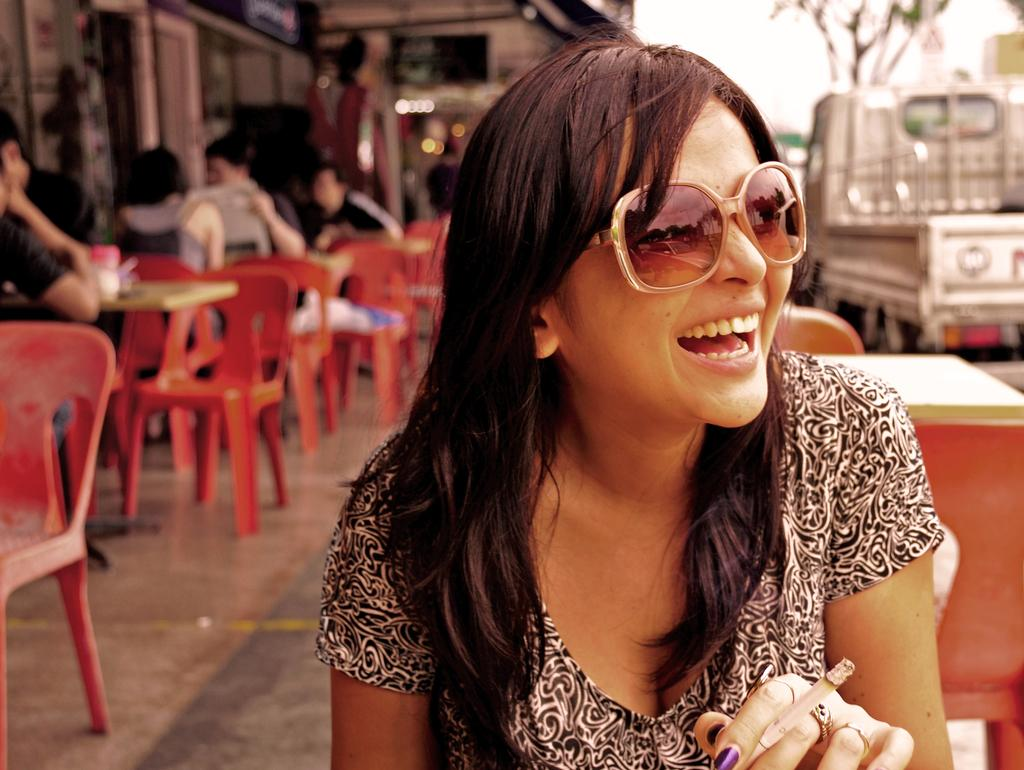Who is present in the image? There is a woman in the image. What is the woman doing in the image? The woman is sitting and smiling. What can be seen in the background of the image? There are chairs, tables, people, a building, and a vehicle in the background of the image. What type of spy equipment can be seen in the woman's hand in the image? There is no spy equipment visible in the woman's hand in the image. What type of cushion is the woman sitting on in the image? The image does not provide information about the type of cushion the woman is sitting on, if any. 